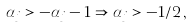<formula> <loc_0><loc_0><loc_500><loc_500>\alpha _ { j } > - \alpha _ { j } - 1 \Rightarrow \alpha _ { j } > - 1 / 2 \, ,</formula> 